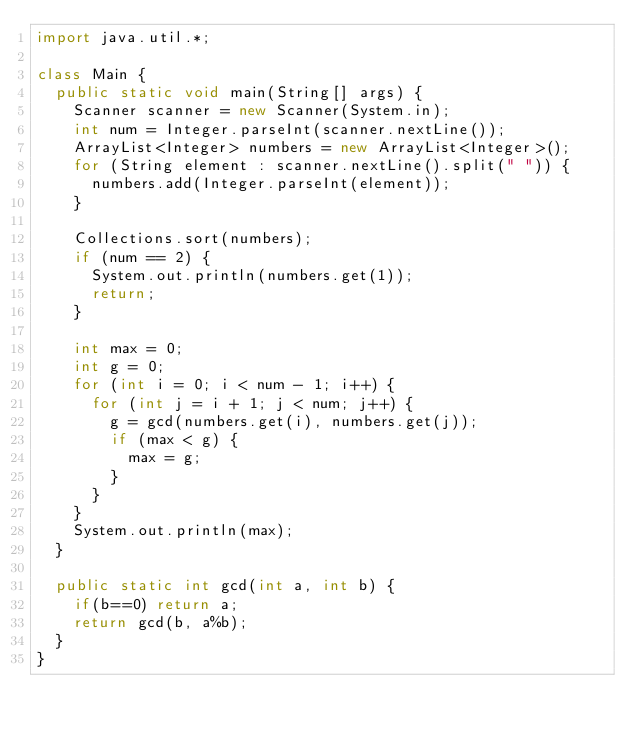<code> <loc_0><loc_0><loc_500><loc_500><_Java_>import java.util.*;

class Main {
  public static void main(String[] args) {
    Scanner scanner = new Scanner(System.in);
    int num = Integer.parseInt(scanner.nextLine());
    ArrayList<Integer> numbers = new ArrayList<Integer>();
    for (String element : scanner.nextLine().split(" ")) {
      numbers.add(Integer.parseInt(element));
    }
    
    Collections.sort(numbers);
    if (num == 2) {
      System.out.println(numbers.get(1));
      return;
    }
    
    int max = 0;
    int g = 0;
    for (int i = 0; i < num - 1; i++) {
      for (int j = i + 1; j < num; j++) {
        g = gcd(numbers.get(i), numbers.get(j));
        if (max < g) {
          max = g;
        }
      }
    }
    System.out.println(max);
  }
  
  public static int gcd(int a, int b) {
    if(b==0) return a;
    return gcd(b, a%b);
  }
}</code> 